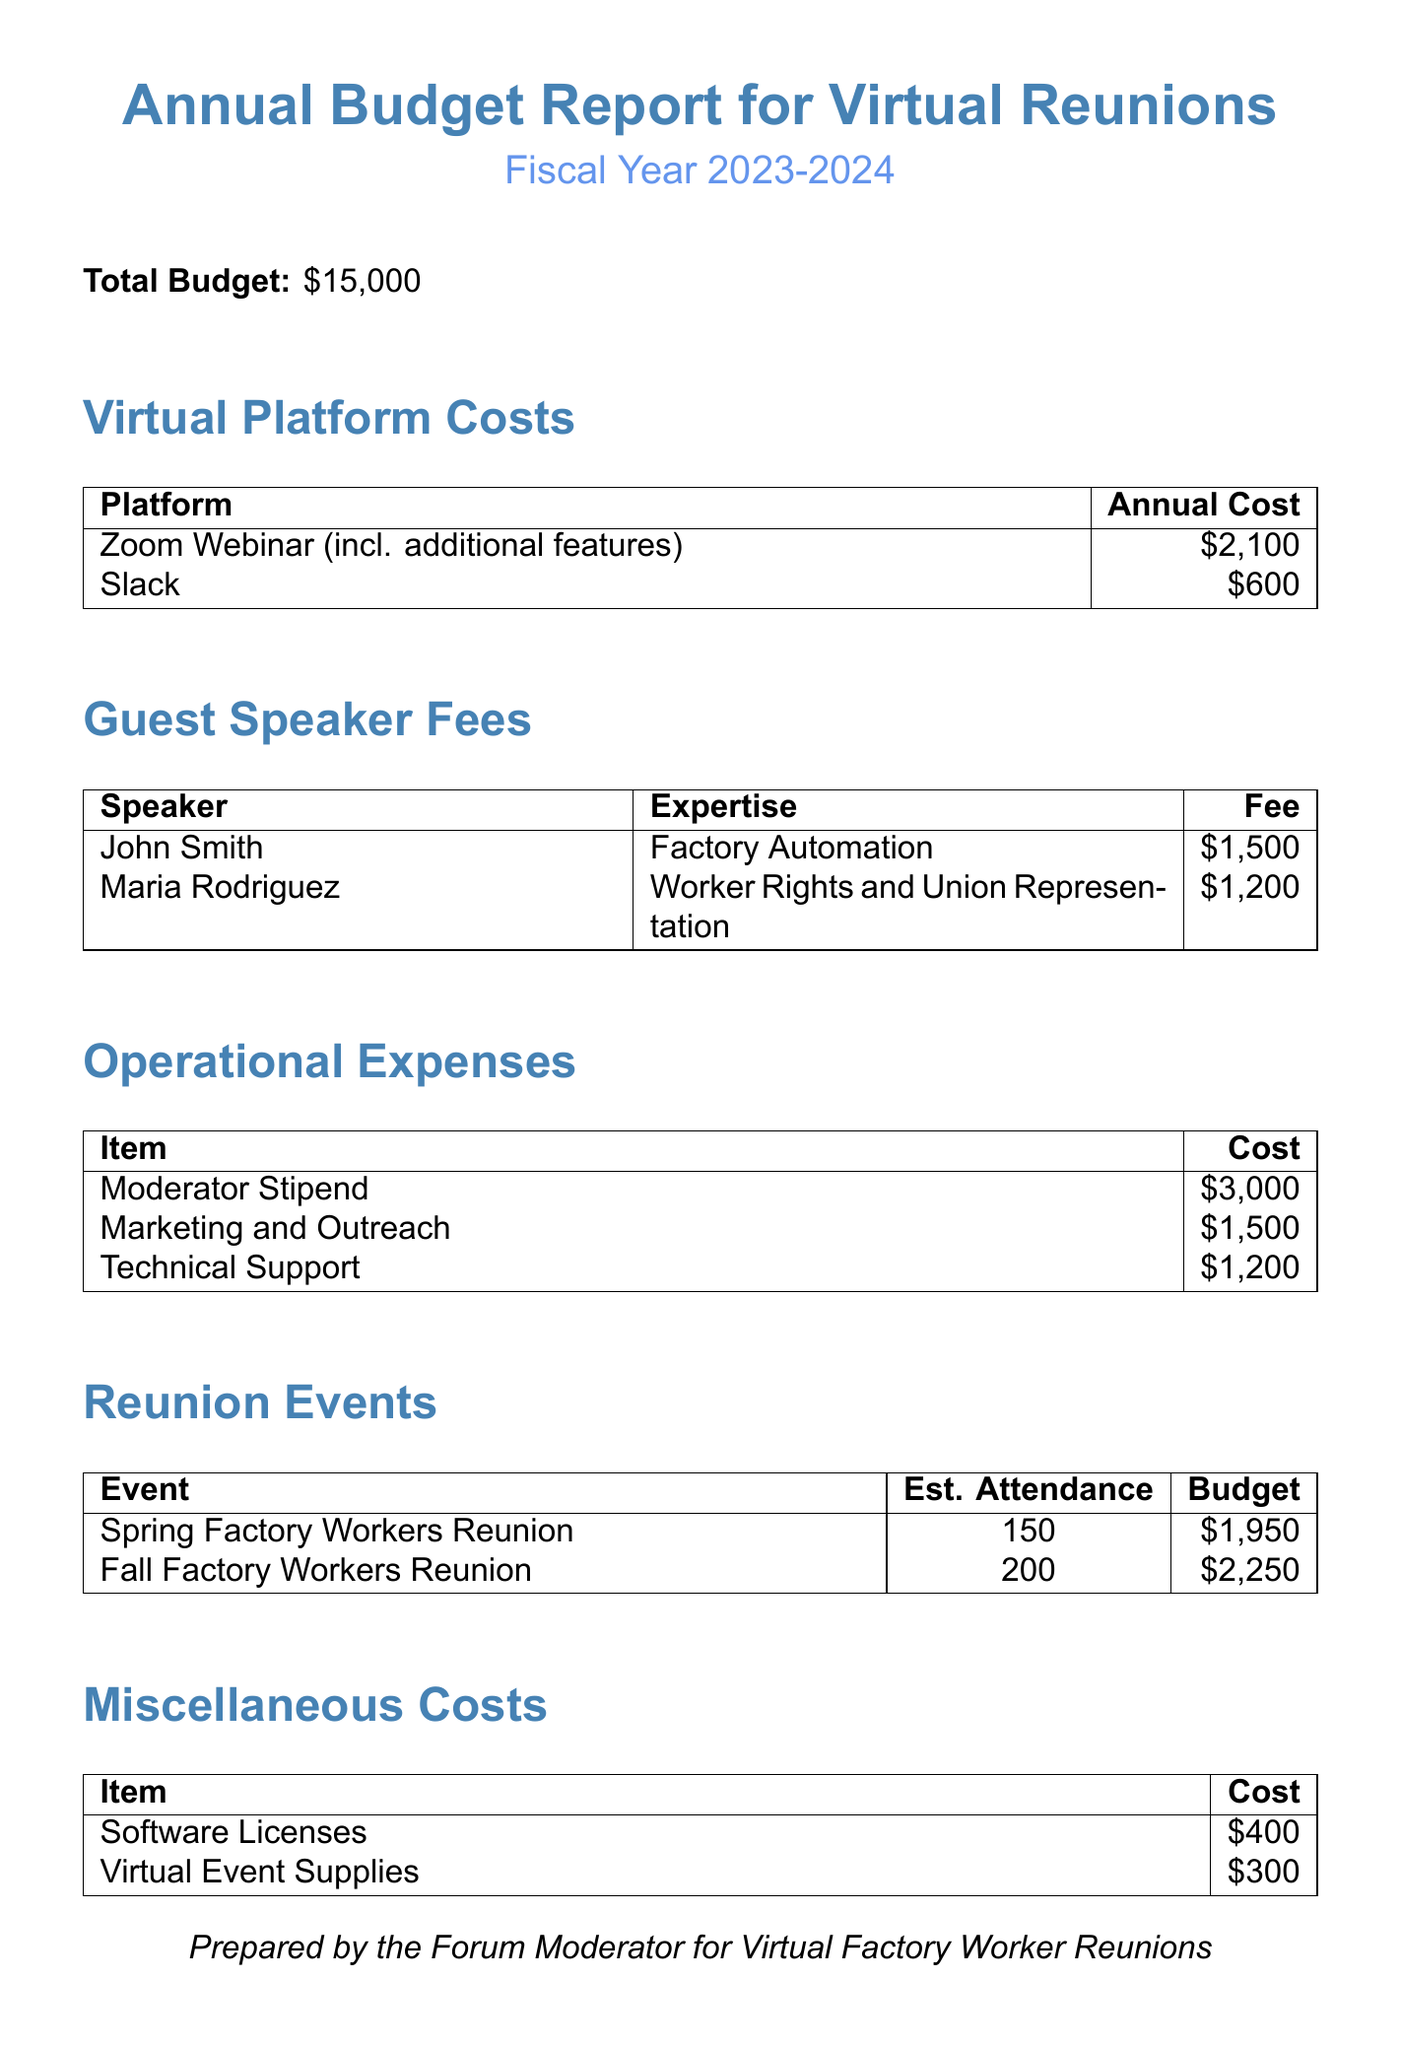What is the total budget? The total budget for the fiscal year is listed in the document as the overall financial allocation for hosting the virtual reunions.
Answer: $15,000 What is the annual subscription cost for Zoom Webinar? The cost listed for the Zoom Webinar platform includes both the annual subscription and additional features.
Answer: $1,800 Who is the guest speaker on Worker Rights? The document provides names of guest speakers along with their areas of expertise.
Answer: Maria Rodriguez How much is allocated for the Fall Factory Workers Reunion? The document details the budget allocation for each reunion event specifically.
Answer: $2,250 What is the total cost for marketing and outreach? Marketing and outreach is listed as an operational expense, reflecting the total amount allocated.
Answer: $1,500 How many estimated attendees are there for the Spring Factory Workers Reunion? The estimated attendance figure is provided for each reunion event in the document.
Answer: 150 What is the total cost for technical support? The technical support cost is specified as part of the operational expenses.
Answer: $1,200 What are the miscellaneous costs for software licenses? The document lists various miscellaneous costs, specifically noting the amount for software licenses.
Answer: $400 What is the total amount allocated for guest speaker fees? The document provides individual fees for each speaker, allowing for the total to be calculated by summing those fees.
Answer: $2,700 